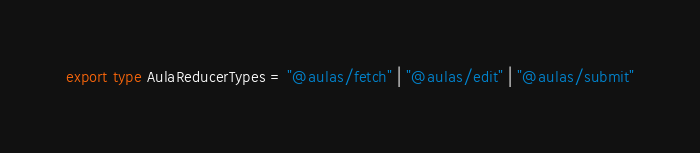<code> <loc_0><loc_0><loc_500><loc_500><_TypeScript_>export type AulaReducerTypes = "@aulas/fetch" | "@aulas/edit" | "@aulas/submit"</code> 